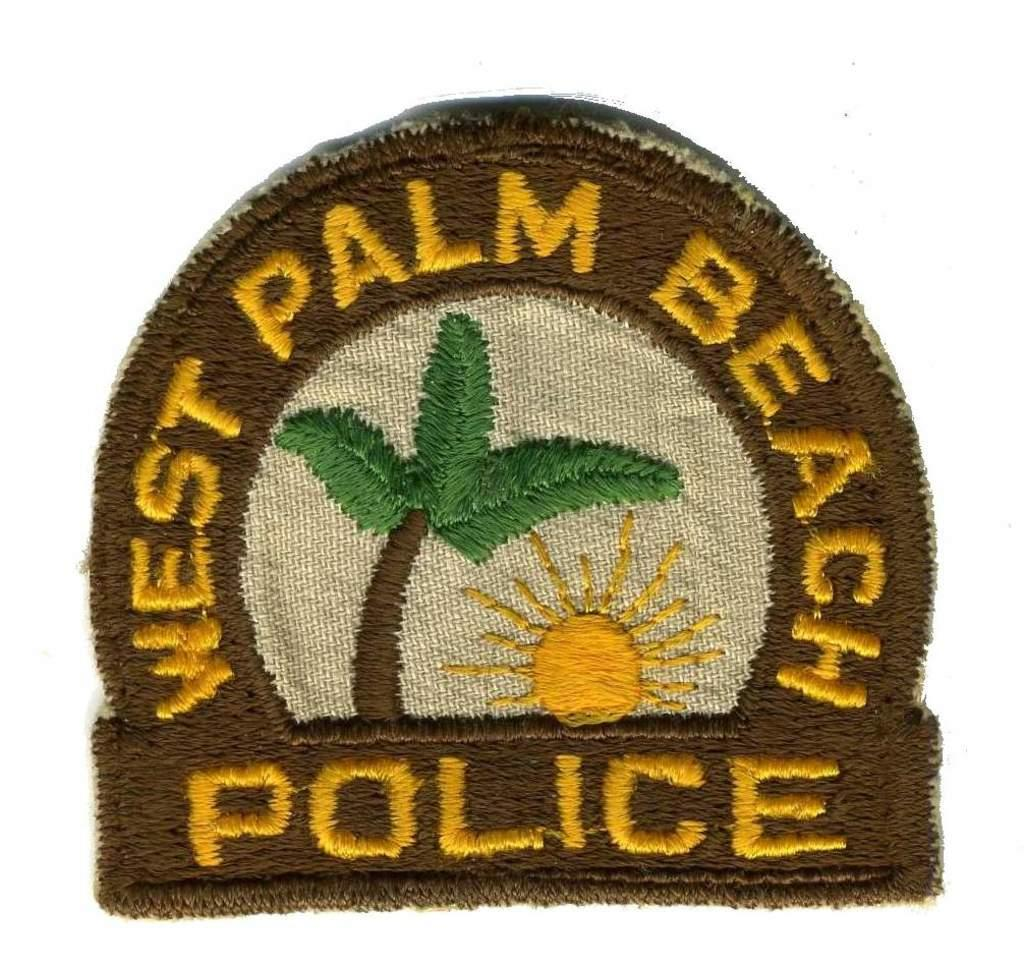<image>
Describe the image concisely. A patch for the West Palm Beach Police has a palm tree and a sun on it. 